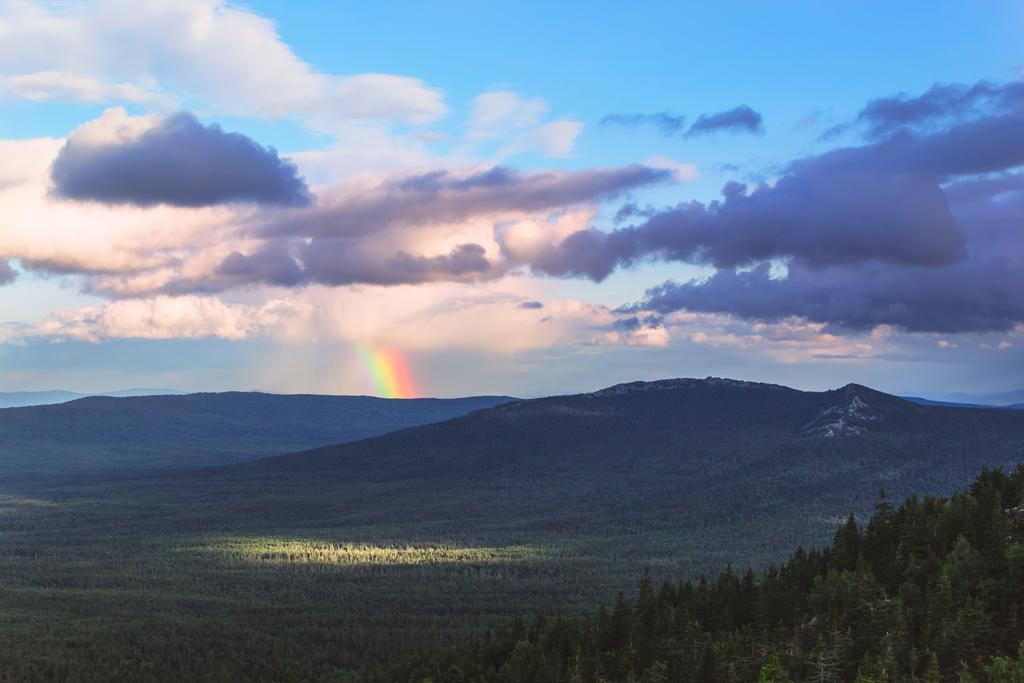Can you describe this image briefly? In this picture I can observe some trees and hills. In the middle of the picture I can observe rainbow in the sky. There are some clouds in the sky. 